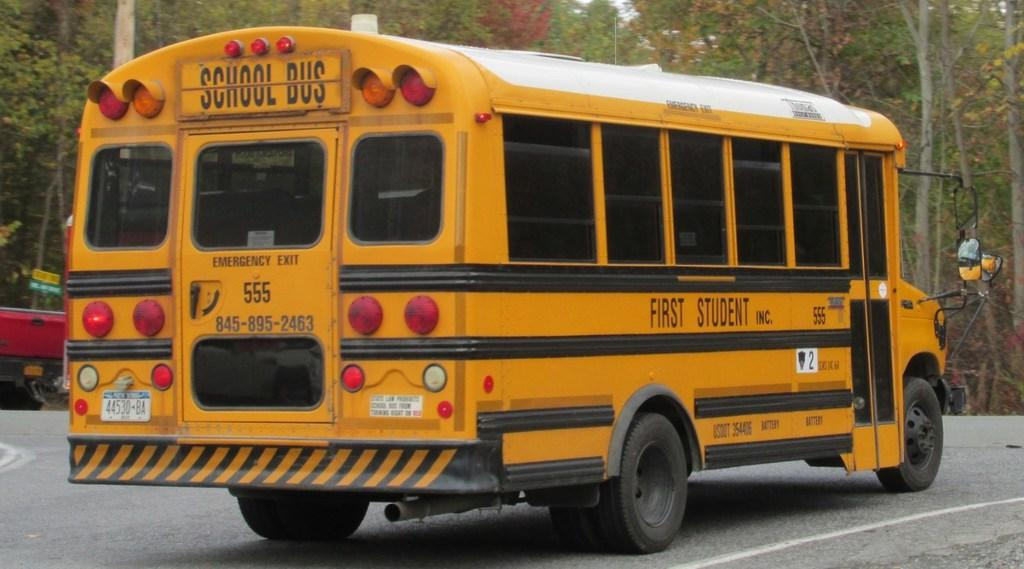What type of vehicle is in the image? There is a school bus in the image. What is the school bus doing in the image? The school bus is moving on the road. What color is the school bus? The school bus is yellow in color. What can be seen in the background of the image? There are trees in the background of the image. What type of hook is hanging from the school bus in the image? There is no hook hanging from the school bus in the image. What meal is being served to the students on the school bus in the image? There is no meal being served on the school bus in the image. 